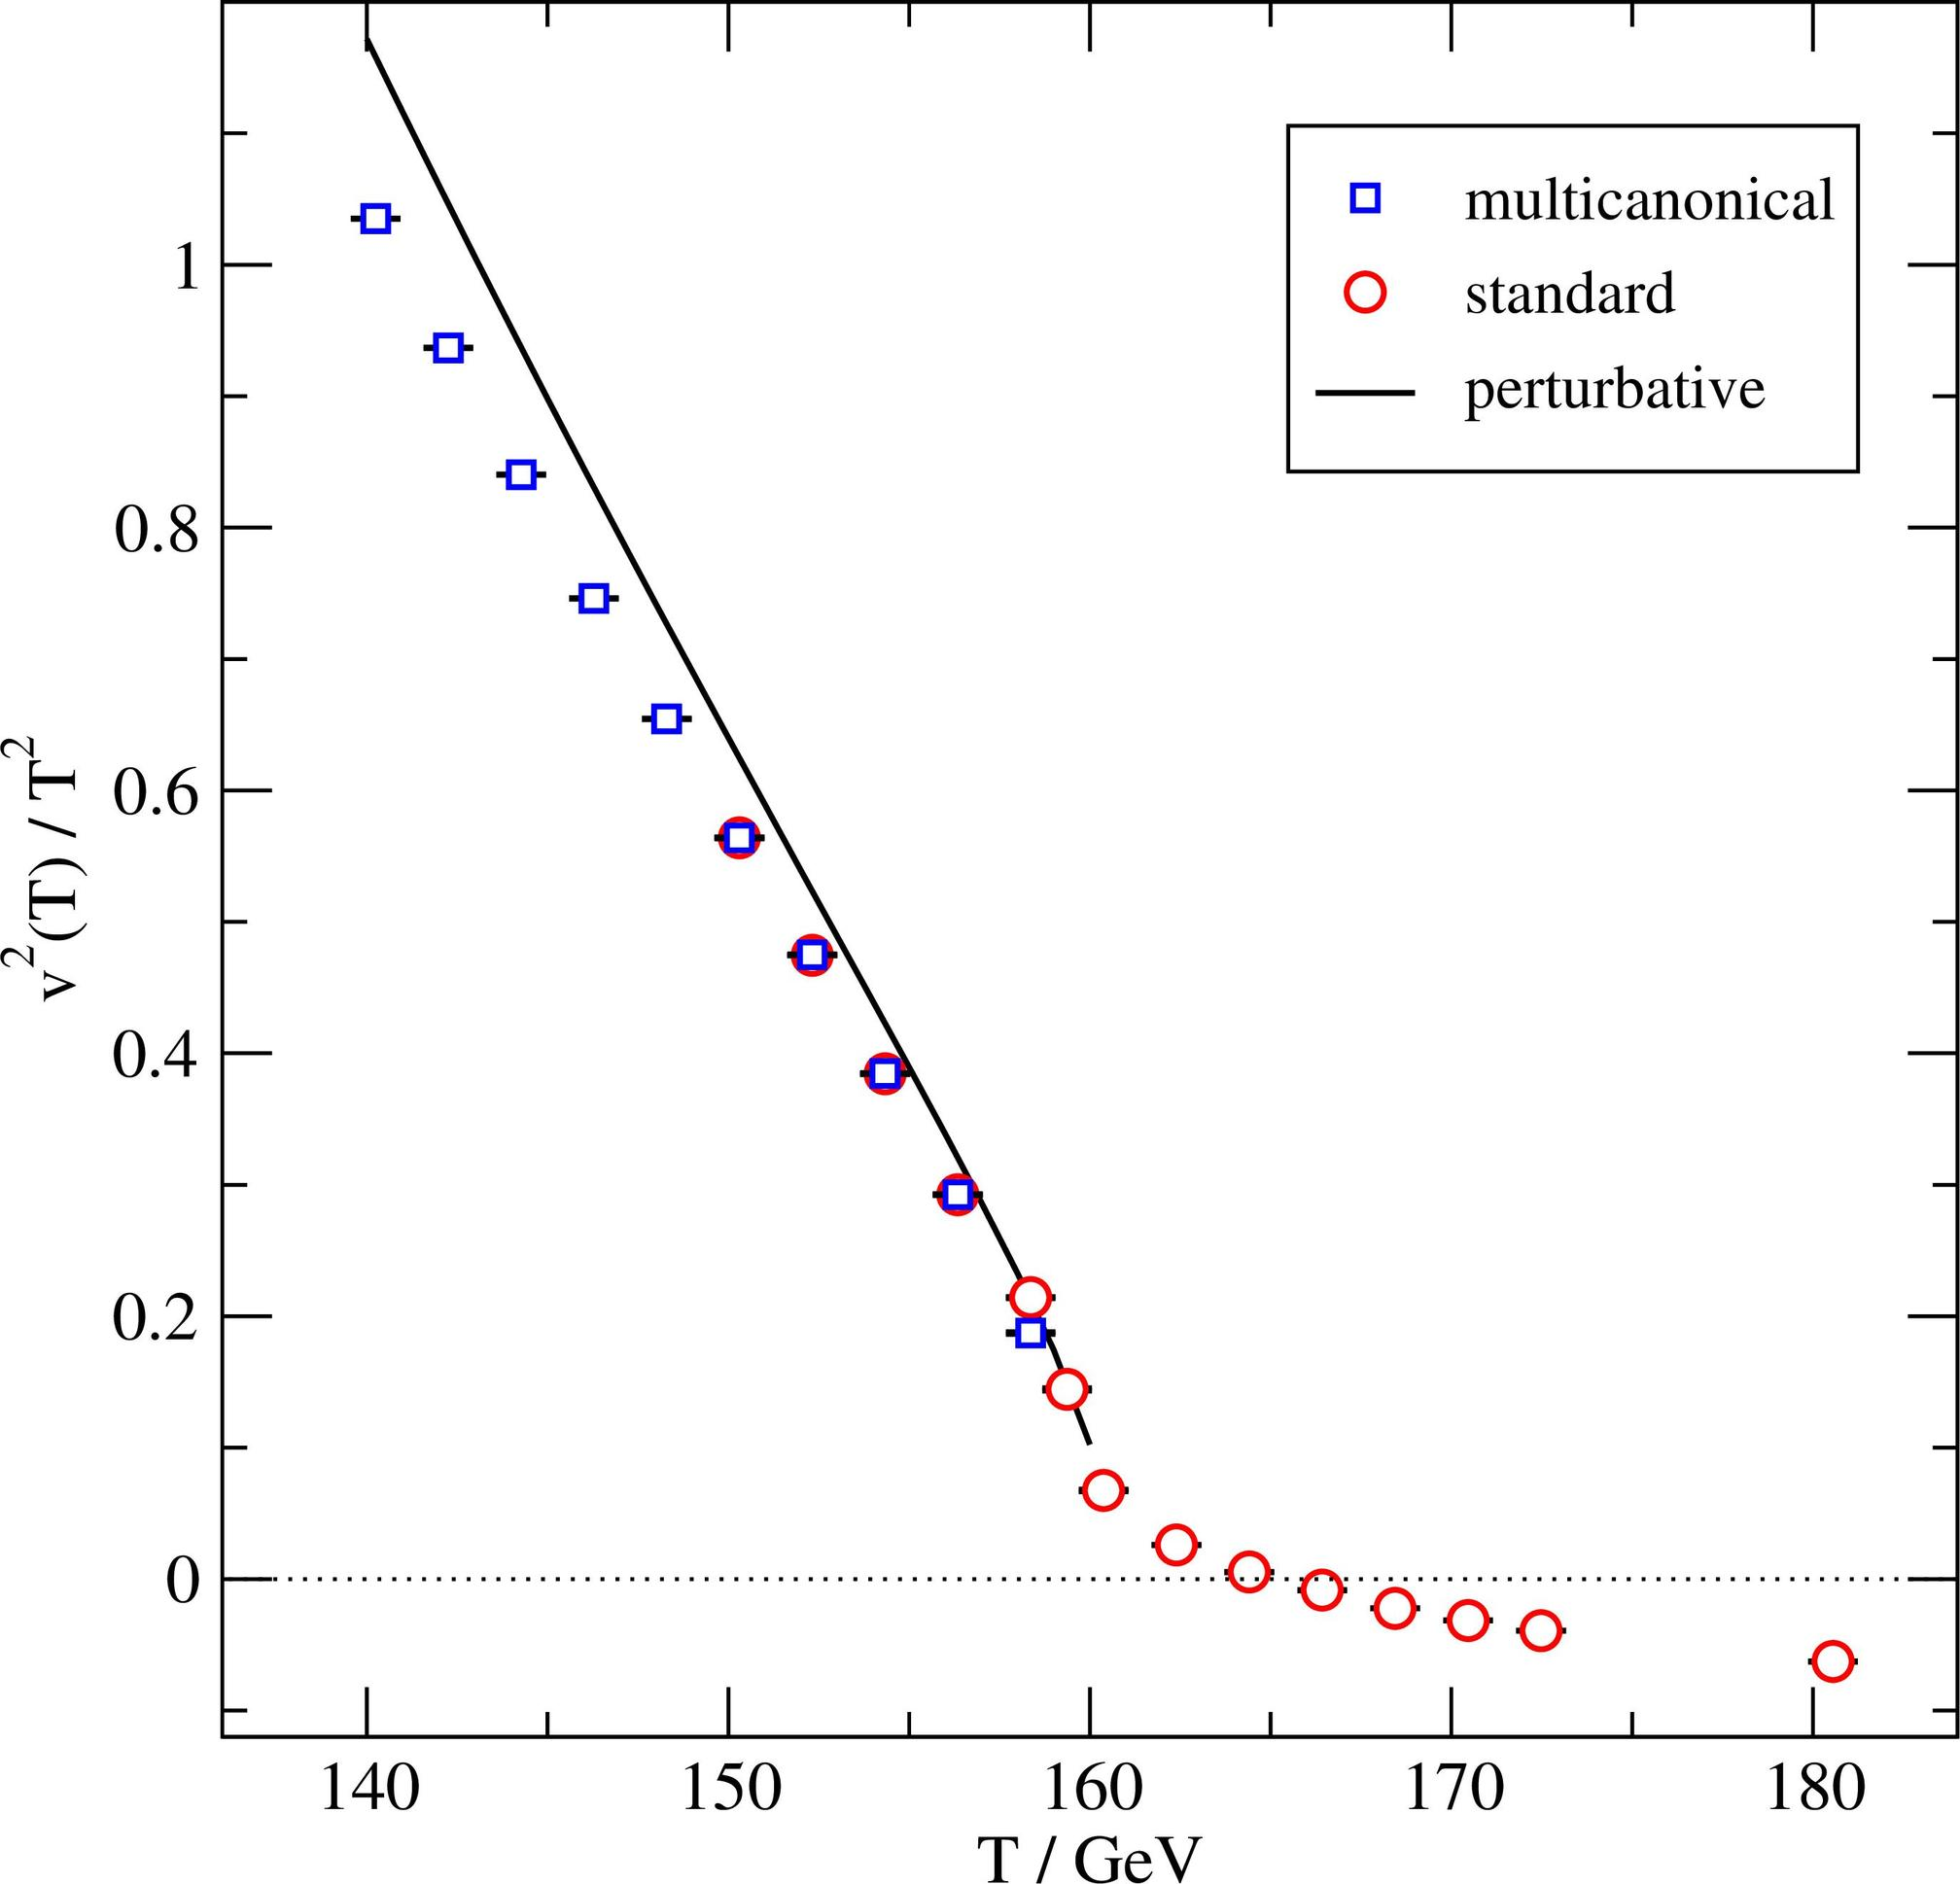What could be the impact of these discrepancies on the field of particle physics? The discrepancies observed between the multicanonical and standard measurements, especially highlighted in the temperature range of 160-170 GeV, could have significant implications for the field of particle physics. These differences might prompt a re-evaluation of existing theoretical models or lead to the development of new ones that better accommodate observed experimental results. Additionally, these discrepancies can help in identifying the limitations of current experimental techniques and suggest areas where methodological advancements are needed. Ultimately, these insights drive the refinement of both theoretical and practical aspects of the field, leading to more accurate and reliable scientific outcomes. 